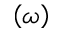<formula> <loc_0><loc_0><loc_500><loc_500>\left ( \omega \right )</formula> 